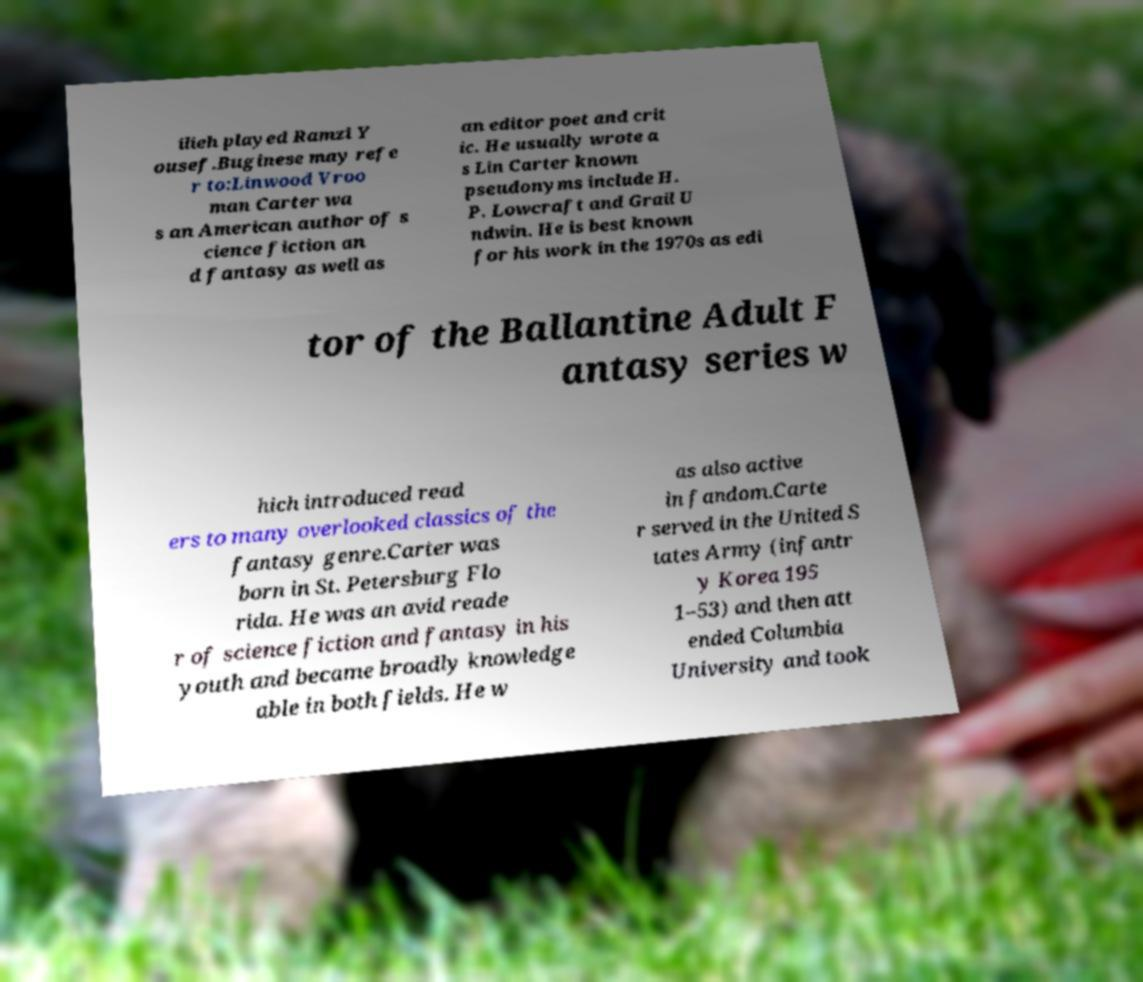I need the written content from this picture converted into text. Can you do that? ilieh played Ramzi Y ousef.Buginese may refe r to:Linwood Vroo man Carter wa s an American author of s cience fiction an d fantasy as well as an editor poet and crit ic. He usually wrote a s Lin Carter known pseudonyms include H. P. Lowcraft and Grail U ndwin. He is best known for his work in the 1970s as edi tor of the Ballantine Adult F antasy series w hich introduced read ers to many overlooked classics of the fantasy genre.Carter was born in St. Petersburg Flo rida. He was an avid reade r of science fiction and fantasy in his youth and became broadly knowledge able in both fields. He w as also active in fandom.Carte r served in the United S tates Army (infantr y Korea 195 1–53) and then att ended Columbia University and took 